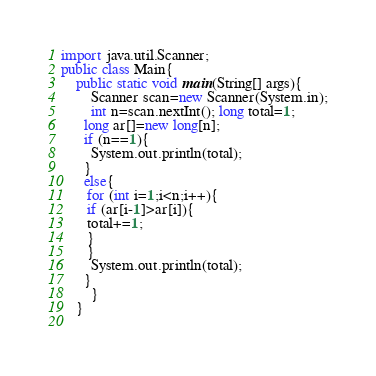<code> <loc_0><loc_0><loc_500><loc_500><_Java_>import java.util.Scanner;
public class Main{
    public static void main(String[] args){
        Scanner scan=new Scanner(System.in);
        int n=scan.nextInt(); long total=1;
      long ar[]=new long[n];
      if (n==1){
        System.out.println(total);
      }
      else{
       for (int i=1;i<n;i++){
       if (ar[i-1]>ar[i]){
       total+=1;
       }
       }
        System.out.println(total);
      }
        }
    }
    
</code> 